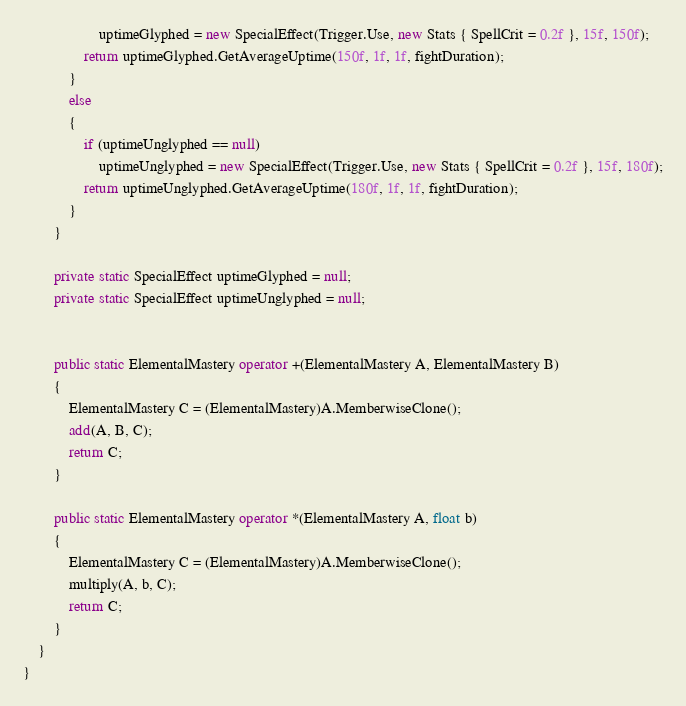Convert code to text. <code><loc_0><loc_0><loc_500><loc_500><_C#_>                    uptimeGlyphed = new SpecialEffect(Trigger.Use, new Stats { SpellCrit = 0.2f }, 15f, 150f);
                return uptimeGlyphed.GetAverageUptime(150f, 1f, 1f, fightDuration);
            }
            else
            {
                if (uptimeUnglyphed == null)
                    uptimeUnglyphed = new SpecialEffect(Trigger.Use, new Stats { SpellCrit = 0.2f }, 15f, 180f);
                return uptimeUnglyphed.GetAverageUptime(180f, 1f, 1f, fightDuration);
            }
        }

        private static SpecialEffect uptimeGlyphed = null;
        private static SpecialEffect uptimeUnglyphed = null;


        public static ElementalMastery operator +(ElementalMastery A, ElementalMastery B)
        {
            ElementalMastery C = (ElementalMastery)A.MemberwiseClone();
            add(A, B, C);
            return C;
        }

        public static ElementalMastery operator *(ElementalMastery A, float b)
        {
            ElementalMastery C = (ElementalMastery)A.MemberwiseClone();
            multiply(A, b, C);
            return C;
        }
    }
}</code> 